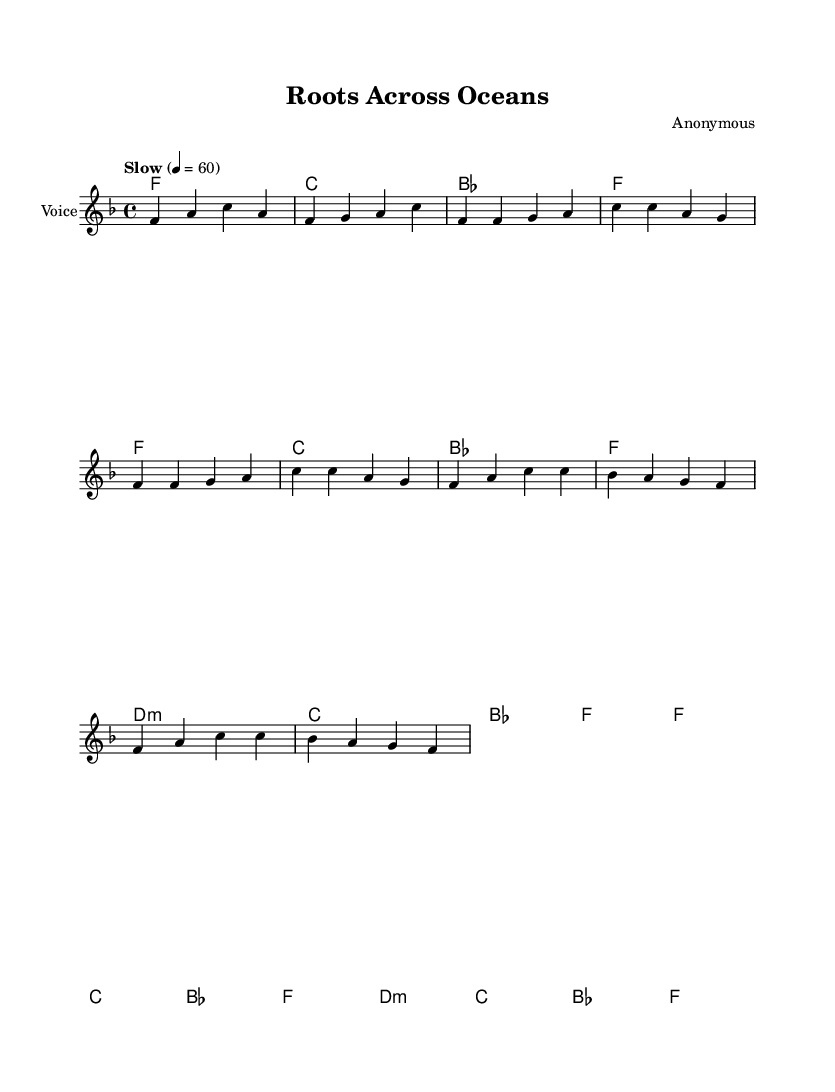What is the key signature of this music? The key signature is indicated by the number of flats or sharps next to the clef at the beginning of the sheet music. In this case, there are no sharps or flats shown, indicating F major.
Answer: F major What is the time signature of this music? The time signature is displayed as a fraction (numerator and denominator) at the beginning of the staff. Here, it's 4 over 4, indicating four beats per measure with a quarter note receiving one beat.
Answer: 4/4 What is the tempo marking for this piece? The tempo is written above the staff as "Slow" with a metronome marking of 60 beats per minute. This tells the performer to play the piece slowly at this speed.
Answer: Slow, 60 How many measures are in the verse? The melody section for the verse consists of four separate measures that contain the notes as indicated in the score, making it easy to count them by examining the bar lines.
Answer: 4 measures What is the first note of the chorus? The first note of the chorus can be found by looking at the melody section; it begins with the note F as indicated in the score.
Answer: F What type of harmony is predominantly used in this piece? By examining the chord symbols used in the score, it becomes clear that this piece employs primarily major and minor chords, particularly F major and D minor, reflecting common harmonic structures in soul music.
Answer: Major and minor 